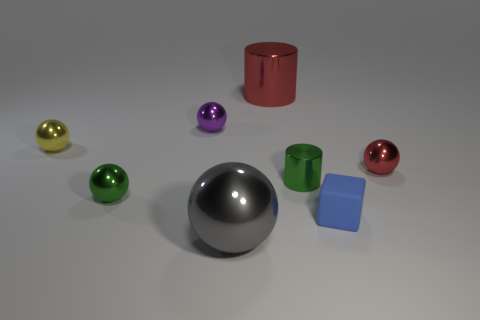Subtract all small red spheres. How many spheres are left? 4 Subtract all red cylinders. How many cylinders are left? 1 Add 1 big yellow matte blocks. How many objects exist? 9 Subtract all cylinders. How many objects are left? 6 Subtract 1 spheres. How many spheres are left? 4 Subtract all gray cylinders. Subtract all purple balls. How many cylinders are left? 2 Subtract all brown balls. How many red cubes are left? 0 Subtract all small red matte balls. Subtract all yellow metallic balls. How many objects are left? 7 Add 8 green shiny spheres. How many green shiny spheres are left? 9 Add 3 small metallic blocks. How many small metallic blocks exist? 3 